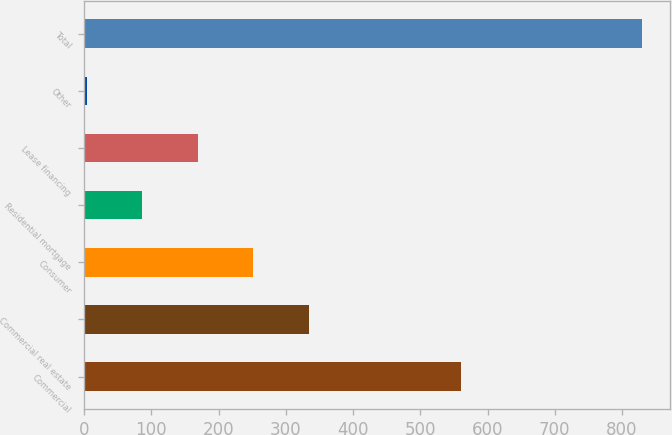Convert chart. <chart><loc_0><loc_0><loc_500><loc_500><bar_chart><fcel>Commercial<fcel>Commercial real estate<fcel>Consumer<fcel>Residential mortgage<fcel>Lease financing<fcel>Other<fcel>Total<nl><fcel>560<fcel>334.4<fcel>251.8<fcel>86.6<fcel>169.2<fcel>4<fcel>830<nl></chart> 